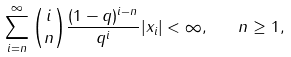Convert formula to latex. <formula><loc_0><loc_0><loc_500><loc_500>\sum _ { i = n } ^ { \infty } { i \choose n } \frac { ( 1 - q ) ^ { i - n } } { q ^ { i } } | x _ { i } | < \infty , \quad n \geq 1 ,</formula> 